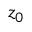<formula> <loc_0><loc_0><loc_500><loc_500>z _ { 0 }</formula> 